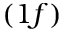Convert formula to latex. <formula><loc_0><loc_0><loc_500><loc_500>( 1 f )</formula> 